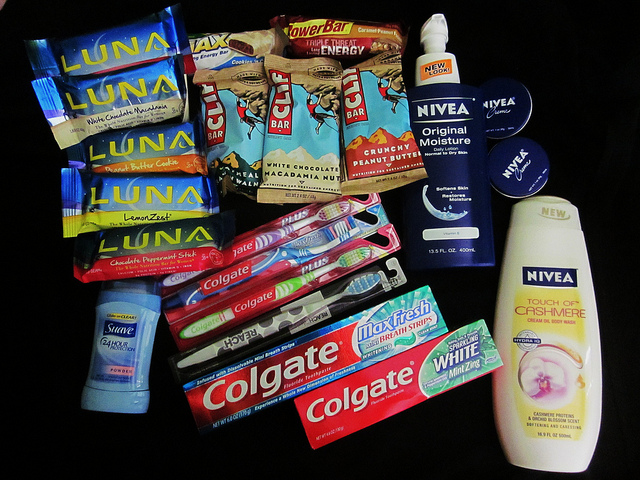Read all the text in this image. Colgate Colgate MaxFresh BREATHS STRIPS PLUS WAX WALN MEAL NUT HACADAHIA CHOCOLATE WHITE BAR BAR CLIF Bar Power THREAT ENERGY MEW NEW BAR PEANUT BUTTER PEANUT CRUNCHY NIVEA MOISTURE Original Cream NIVEA Creme NIVEA Cream NEW NIVEA CASHMERE OF TOUCH SPARKLING WHITE REACH Colgate Colgate gate Stick Chocolate LUNA LemonZest LUNA Guko LUNA LUNA LUNA 